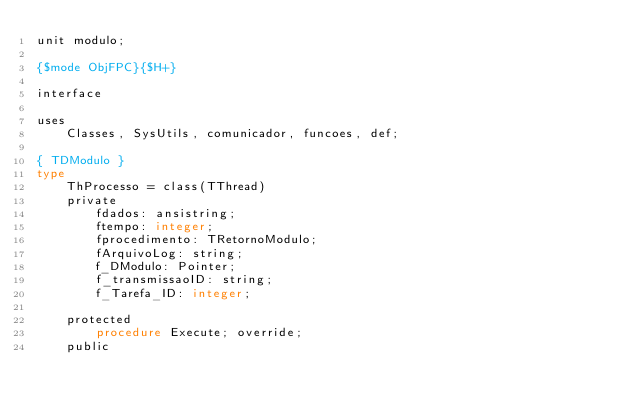<code> <loc_0><loc_0><loc_500><loc_500><_Pascal_>unit modulo;

{$mode ObjFPC}{$H+}

interface

uses
    Classes, SysUtils, comunicador, funcoes, def;

{ TDModulo }
type
    ThProcesso = class(TThread)
    private
        fdados: ansistring;
        ftempo: integer;
        fprocedimento: TRetornoModulo;
        fArquivoLog: string;
        f_DModulo: Pointer;
        f_transmissaoID: string;
        f_Tarefa_ID: integer;

    protected
        procedure Execute; override;
    public</code> 